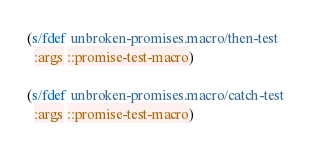Convert code to text. <code><loc_0><loc_0><loc_500><loc_500><_Clojure_>
(s/fdef unbroken-promises.macro/then-test
  :args ::promise-test-macro)

(s/fdef unbroken-promises.macro/catch-test
  :args ::promise-test-macro)
</code> 